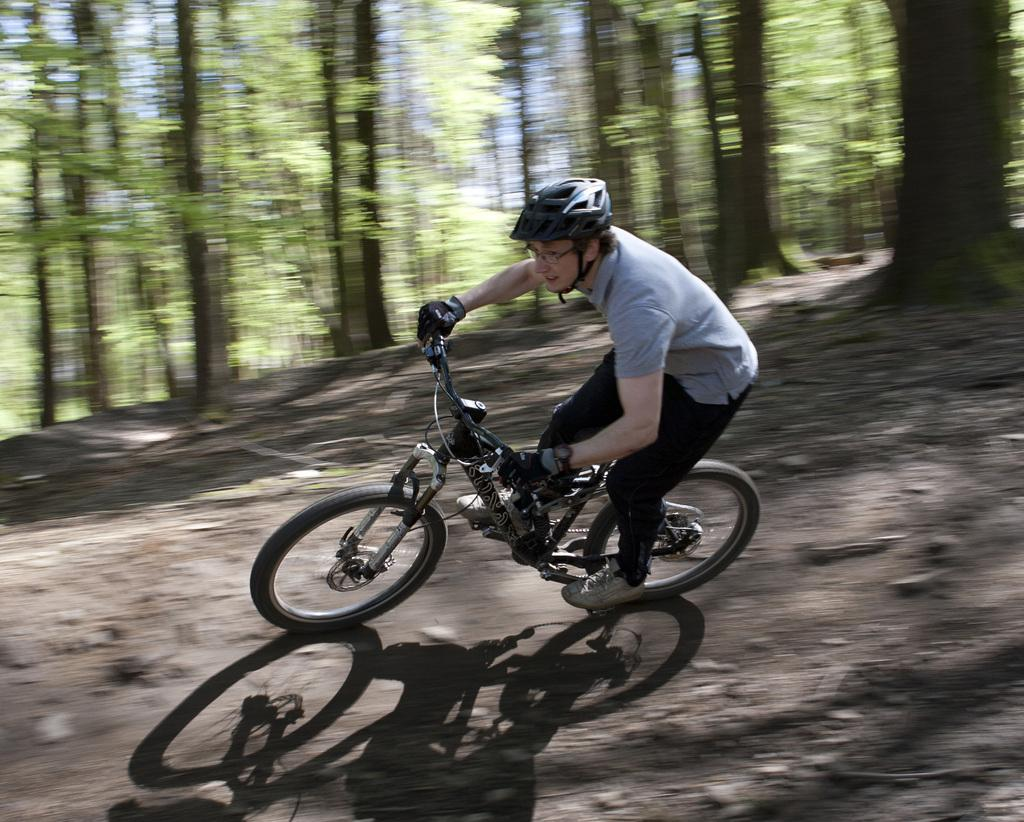What is the person in the image doing? The person is riding a bicycle. What protective gear is the person wearing? The person is wearing a helmet. What type of eyewear is the person wearing? The person is wearing spectacles. What can be seen in the background of the image? There is a group of trees in the background of the image. How does the person in the image wash their hands while riding the bicycle? The person in the image is not washing their hands, as there is no indication of any water or soap in the image. 